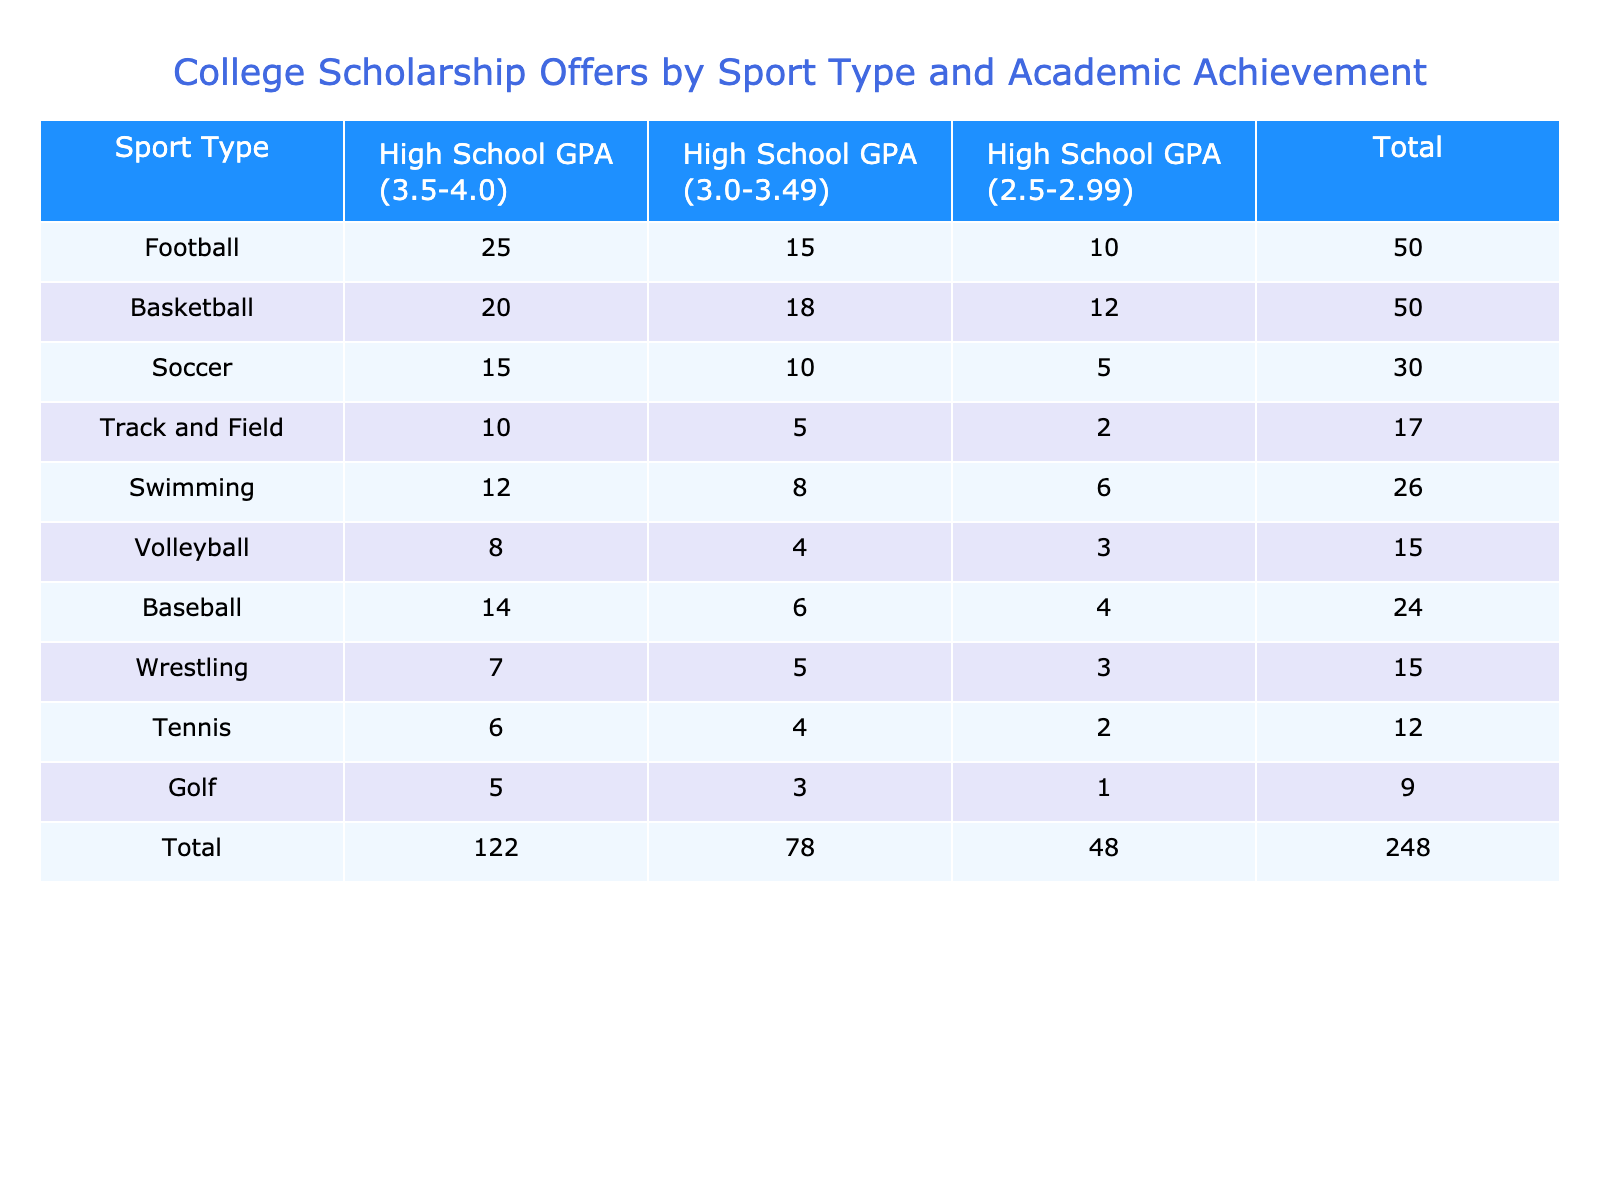What sport had the highest scholarship offers for students with a GPA between 3.5 and 4.0? The table shows that Football had the highest number of scholarship offers at 25 for students with a GPA between 3.5 and 4.0.
Answer: Football What is the total number of scholarship offers for Swimming? To find the total number of scholarship offers for Swimming, we can look at the Swimming row and sum the values: 12 (GPA 3.5-4.0) + 8 (GPA 3.0-3.49) + 6 (GPA 2.5-2.99) = 26.
Answer: 26 How many more scholarship offers were there for Basketball compared to Volleyball for students with a GPA of 3.0-3.49? Basketball had 18 offers and Volleyball had 4 offers for the 3.0-3.49 GPA category. So, the difference is 18 - 4 = 14.
Answer: 14 Is there a sport that had the same number of total scholarship offers as Tennis? Looking at the total offers of 6 for Tennis and comparing it with other rows, we can see that Golf also has 9 total offers, and thus no other sport has the exact same total of 6 offers as Tennis.
Answer: No What percentage of total scholarship offers did Track and Field receive from the overall total? Track and Field received a total of 17 scholarship offers (10 + 5 + 2 = 17). The overall total (found from the last row in the table) is 192 (25 + 20 + 15 + 10 + 12 + 8 + 14 + 7 + 6 + 5 = 192). To find the percentage, divide 17 by 192 and multiply by 100: (17/192) * 100 ≈ 8.85%.
Answer: 8.85% Which GPA category had the lowest total number of scholarship offers? By adding up the totals for each GPA category (e.g., for 3.5-4.0: 25 + 20 + 15 + 10 +... for all sports), we find that the category with the lowest total is 2.5-2.99, which sums up to 52.
Answer: 2.5-2.99 What is the average number of scholarship offers across all sports for the GPA category of 3.0-3.49? To find the average, we add up all the values in the 3.0-3.49 GPA category (15 + 18 + 10 + 5 + 8 + 4 + 6 + 5 + 4 + 3) = 82. Since there are 10 sports, we divide: 82/10 = 8.2.
Answer: 8.2 Which sport has the second highest total scholarship offers and how many offers does it have? The total scholarship offers for each sport can be determined from the last column before adding totals. After reviewing, Basketball comes second with 60 offers overall (20 + 18 + 12 = 60).
Answer: Basketball, 60 How many sports had fewer than 10 scholarship offers for a GPA of 2.5-2.99? Reviewing the 2.5-2.99 column, we see only Track & Field (2), Soccer (5), and Volleyball (3) had fewer than 10 offers. In total, this amounts to 3 sports.
Answer: 3 